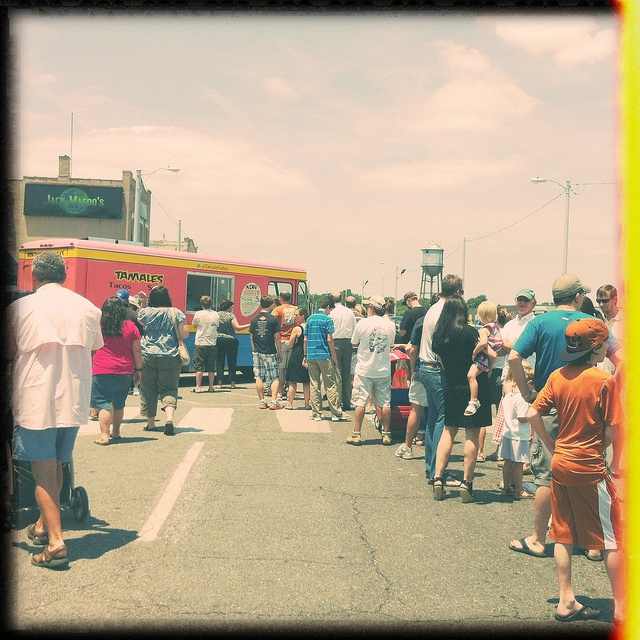Describe the objects in this image and their specific colors. I can see people in black, gray, teal, and tan tones, people in black, lightgray, gray, and tan tones, people in black, gray, brown, and orange tones, bus in black, salmon, gray, tan, and brown tones, and people in black, teal, gray, and tan tones in this image. 